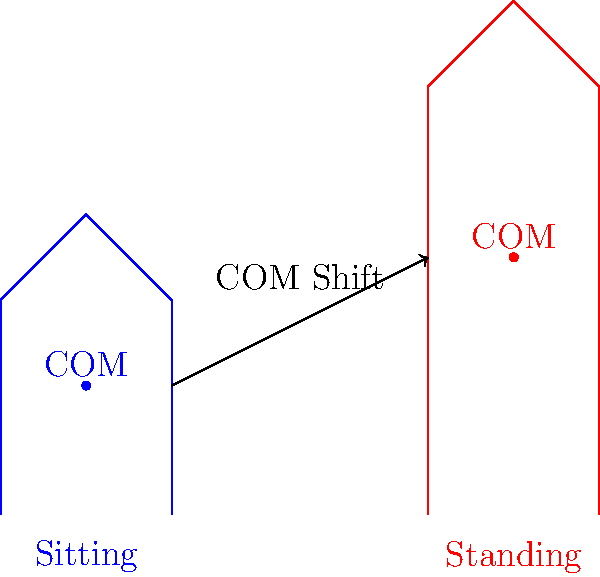As an expert in helping immigrants prepare for job interviews, you want to explain the concept of center of mass shift during body movements. When a person transitions from sitting to standing, in which direction does their center of mass (COM) primarily shift, and why is this knowledge relevant for maintaining balance during interviews? To understand the center of mass shift when transitioning from sitting to standing, let's break it down step-by-step:

1. In the sitting position:
   - The body is compact and lower to the ground.
   - The center of mass is located approximately at the level of the lower abdomen.

2. During the transition to standing:
   - The body extends upward and becomes more vertical.
   - The arms and torso move upward and slightly forward.
   - The legs straighten, pushing the body upward.

3. In the standing position:
   - The body is fully extended vertically.
   - The center of mass moves upward and slightly forward.

4. The primary shift of the center of mass is:
   - Upward: Due to the overall extension of the body.
   - Slightly forward: Because the body leans forward slightly to maintain balance.

5. The magnitude of the shift can be approximated:
   - Vertically: About 50% of the person's sitting height.
   - Horizontally: Approximately 5-10% of the person's height forward.

6. Relevance to maintaining balance during interviews:
   - Understanding this shift helps in smooth transitions between sitting and standing.
   - It's important for maintaining composure and avoiding awkward movements.
   - Proper balance during these transitions projects confidence and professionalism.
   - Awareness of body mechanics can help reduce nervousness and improve overall presence.

The knowledge of this biomechanical principle can help interviewees appear more poised and self-assured during crucial moments in an interview, such as when greeting the interviewer or concluding the meeting.
Answer: Upward and slightly forward; improves poise and professionalism during interviews. 